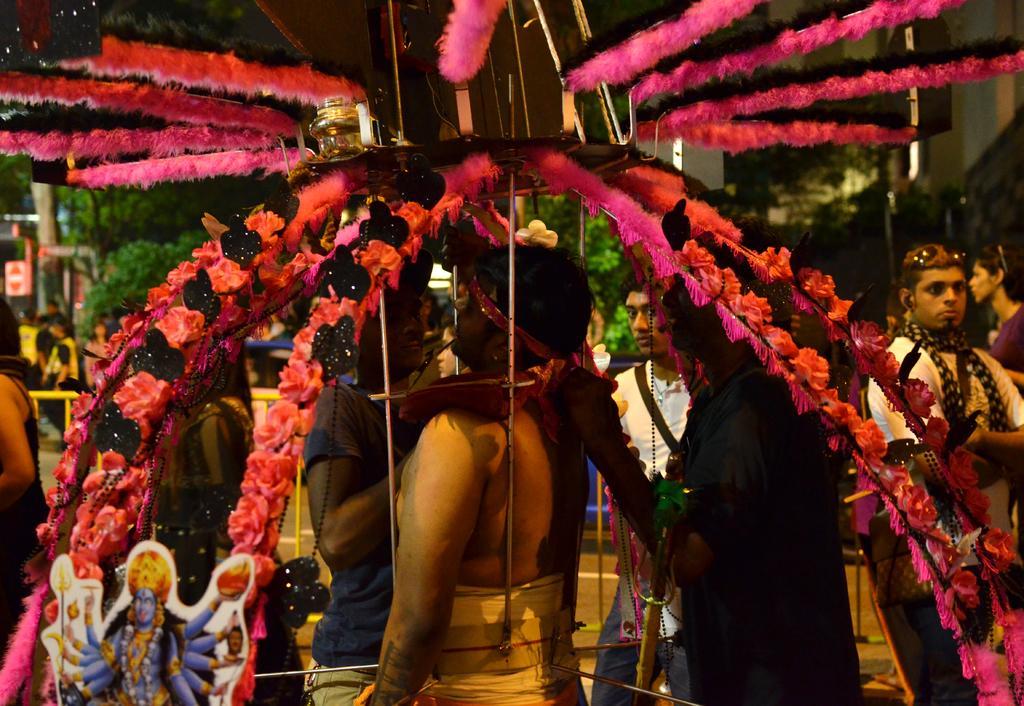Can you describe this image briefly? In this picture we can see some people are standing, a person in the front is carrying a metal stand which is decorated with flowers and ribbons, in the background there are some trees, on the left side there is a board, we can see a sticker at the left bottom. 